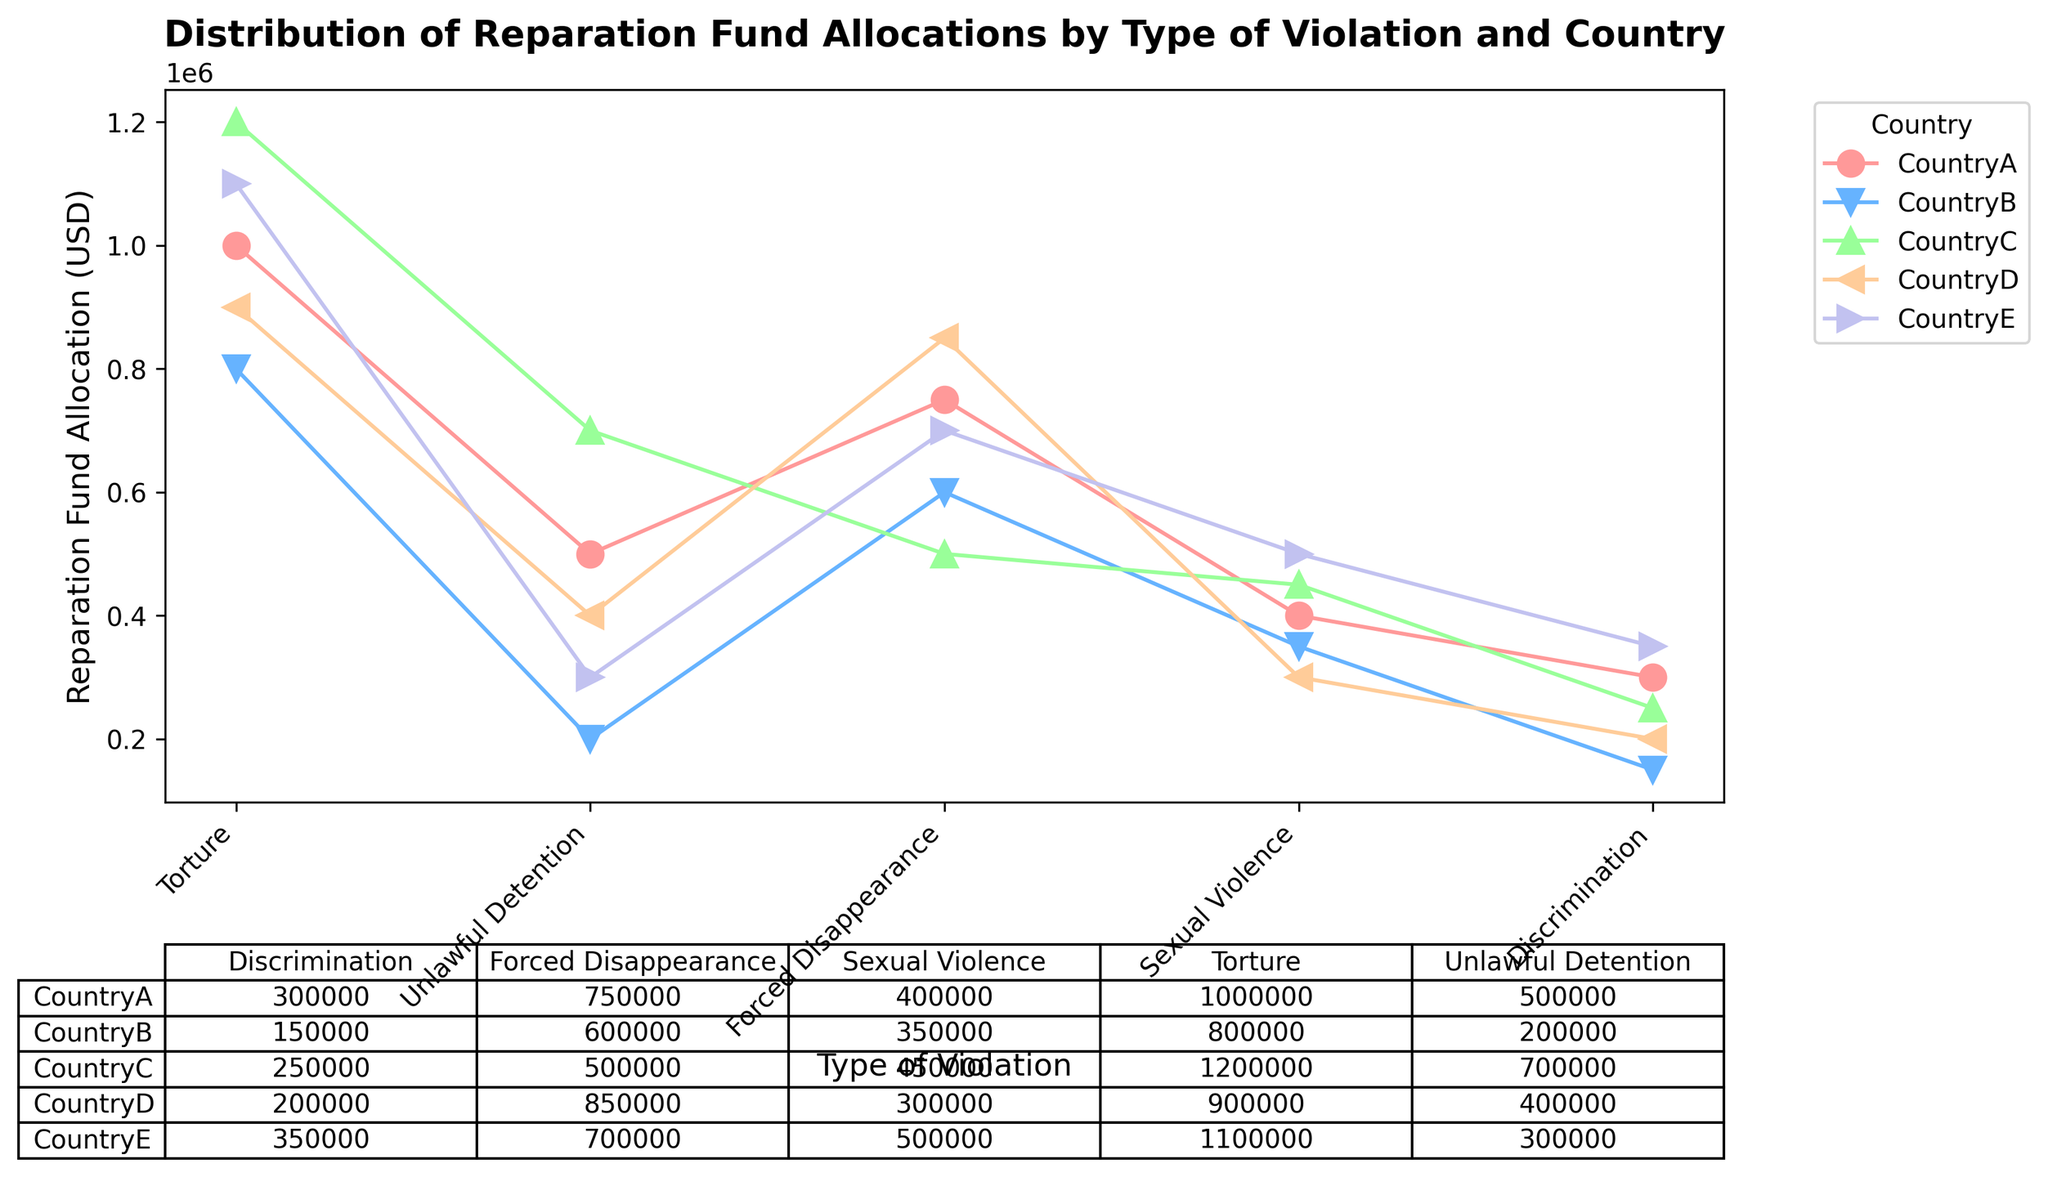What is the total reparation fund allocation for CountryA? Sum all allocates for CountryA specified on the y-axis. Adding (1000000 + 500000 + 750000 + 400000 + 300000) results in 2950000 USD
Answer: 2950000 USD Which country has allocated the most funds for Sexual Violence? Compare the allocations for Sexual Violence across all countries from the respective data points and identify the highest value as CountryE with 500000 USD
Answer: CountryE Are there more funds allocated for Torture or Unlawful Detention in CountryB? Compare the two values for CountryB. Torture has 800000 USD while Unlawful Detention has 200000 USD; therefore, Torture receives more funds
Answer: Torture Which country has the least allocation for Discrimination? Compare the allocation for Discrimination across all countries, identifying that CountryB has the least allocation at 150000 USD
Answer: CountryB What is the average allocation for Forced Disappearance in all countries? Sum the allocation for Forced Disappearance across each country (750000 + 600000 + 500000 + 850000 + 700000 = 3400000) and divide by the number of countries (5), leading to an average of 680000 USD
Answer: 680000 USD Does CountryD allocate more funds for Torture or Sexual Violence? Compare the two values. Torture has 900000 USD while Sexual Violence has 300000 USD; thus more funds are allocated for Torture
Answer: Torture Which type of violation in CountryC has the highest allocation? Analyzing CountryC’s data points for each type of violation, we find that Torture has the highest allocation at 1200000 USD
Answer: Torture Rank the countries from highest to lowest in terms of total reparation funds allocated for Unlawful Detention. Sum the allocations for Unlawful Detention. Rankings are CountryC (700000), CountryA (500000), CountryD (400000), CountryE (300000), CountryB (200000)
Answer: CountryC, CountryA, CountryD, CountryE, CountryB What is the difference in reparation allocations between Torture and Sexual Violence in CountryE? Calculate the difference between the two amounts: 1100000 USD for Torture minus 500000 USD for Sexual Violence results in a difference of 600000 USD
Answer: 600000 USD Which country has the most balanced allocation across different types of violations? A balanced allocation implies the smallest spread between highest and lowest allocations. You must observe the differences visually. CountryC and CountryE appear close, with CountryC having larger spreads making CountryE slightly better
Answer: CountryE 